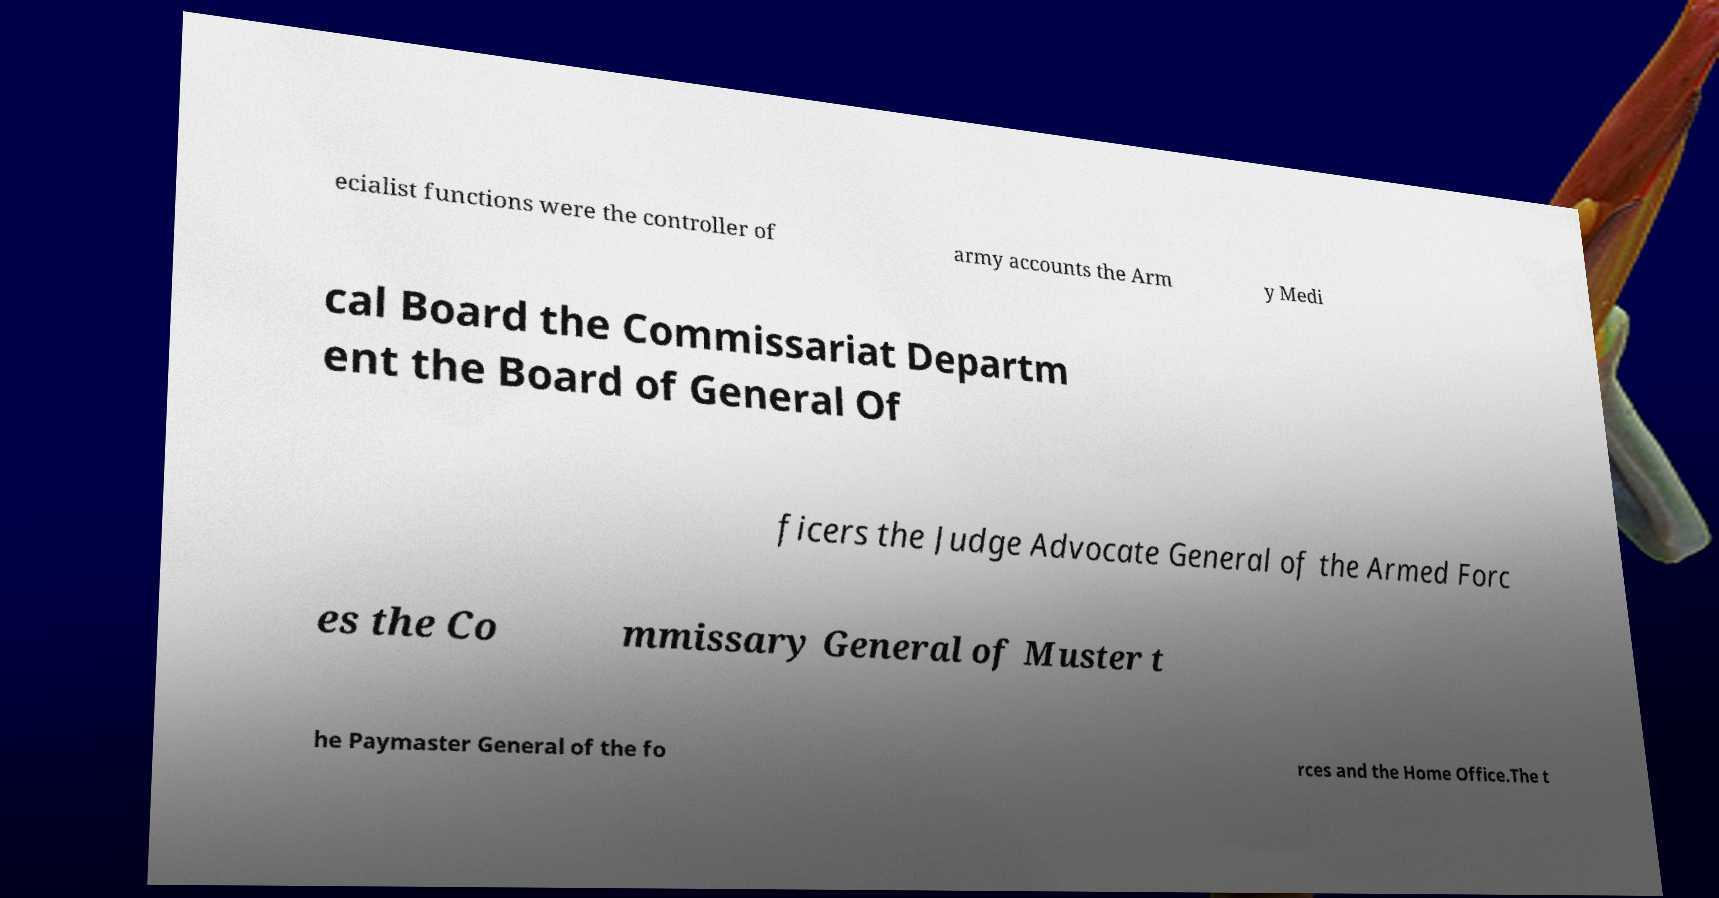There's text embedded in this image that I need extracted. Can you transcribe it verbatim? ecialist functions were the controller of army accounts the Arm y Medi cal Board the Commissariat Departm ent the Board of General Of ficers the Judge Advocate General of the Armed Forc es the Co mmissary General of Muster t he Paymaster General of the fo rces and the Home Office.The t 